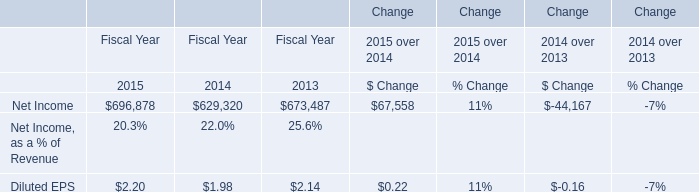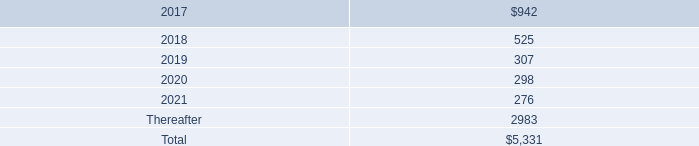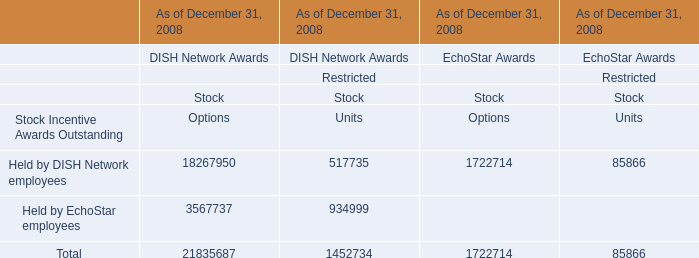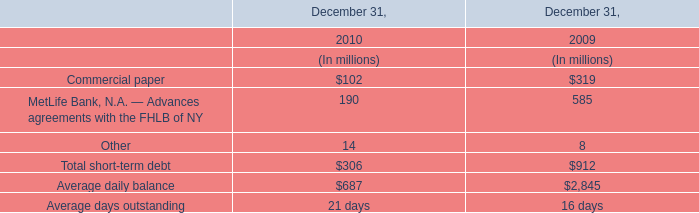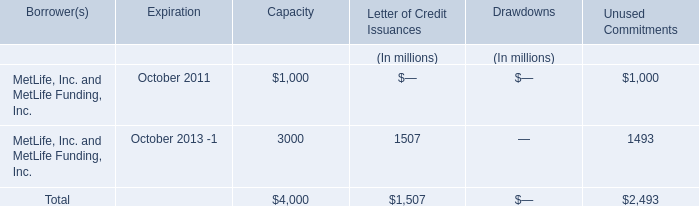What is the growing rate of Total short-term debt in the years with the least Commercial paper? 
Computations: ((306 - 912) / 306)
Answer: -1.98039. 